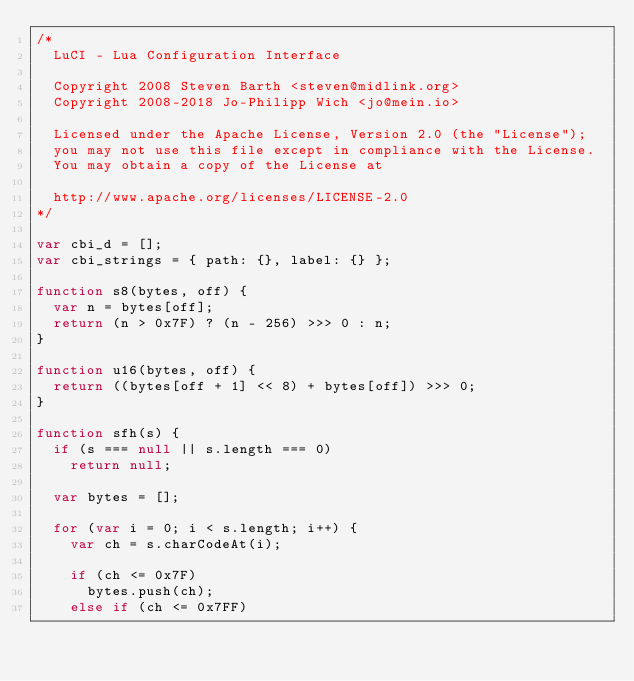<code> <loc_0><loc_0><loc_500><loc_500><_JavaScript_>/*
	LuCI - Lua Configuration Interface

	Copyright 2008 Steven Barth <steven@midlink.org>
	Copyright 2008-2018 Jo-Philipp Wich <jo@mein.io>

	Licensed under the Apache License, Version 2.0 (the "License");
	you may not use this file except in compliance with the License.
	You may obtain a copy of the License at

	http://www.apache.org/licenses/LICENSE-2.0
*/

var cbi_d = [];
var cbi_strings = { path: {}, label: {} };

function s8(bytes, off) {
	var n = bytes[off];
	return (n > 0x7F) ? (n - 256) >>> 0 : n;
}

function u16(bytes, off) {
	return ((bytes[off + 1] << 8) + bytes[off]) >>> 0;
}

function sfh(s) {
	if (s === null || s.length === 0)
		return null;

	var bytes = [];

	for (var i = 0; i < s.length; i++) {
		var ch = s.charCodeAt(i);

		if (ch <= 0x7F)
			bytes.push(ch);
		else if (ch <= 0x7FF)</code> 